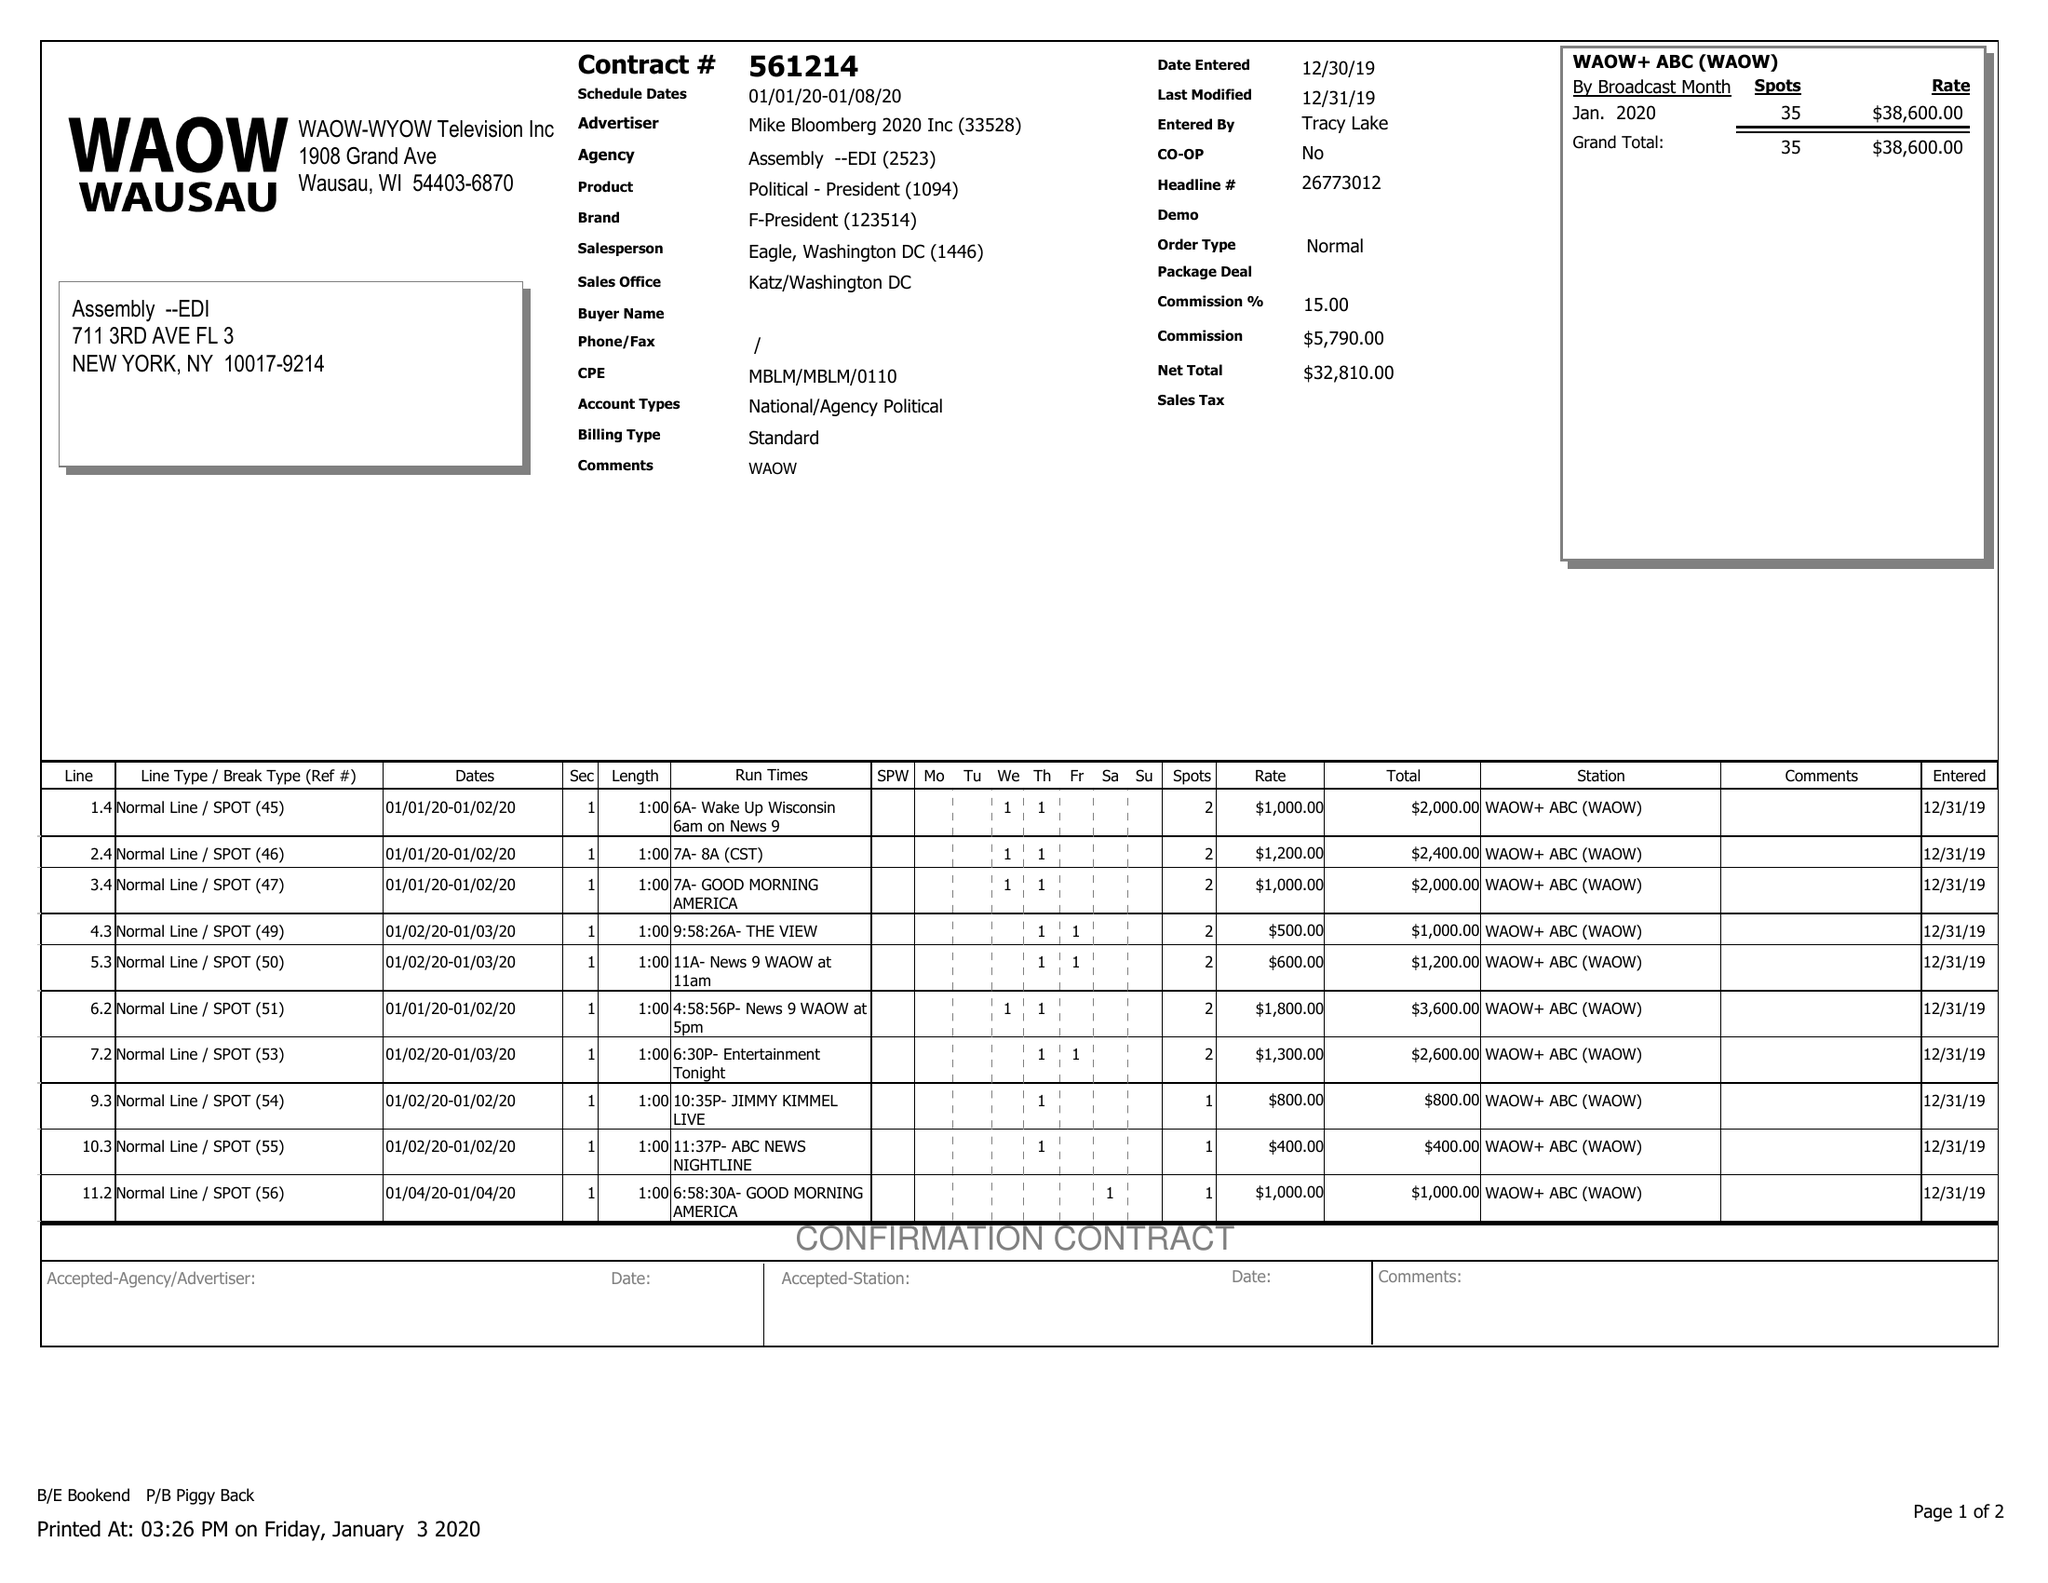What is the value for the flight_from?
Answer the question using a single word or phrase. 01/01/20 